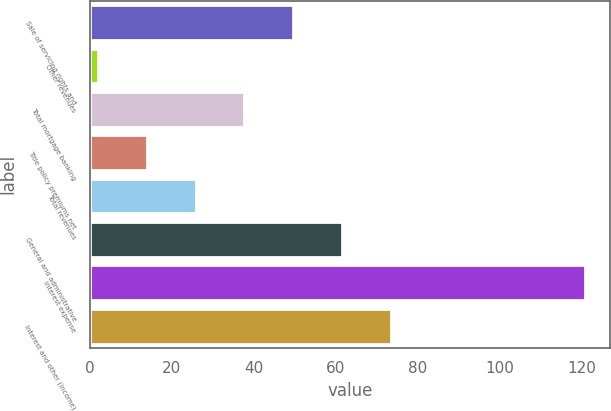Convert chart to OTSL. <chart><loc_0><loc_0><loc_500><loc_500><bar_chart><fcel>Sale of servicing rights and<fcel>Other revenues<fcel>Total mortgage banking<fcel>Title policy premiums net<fcel>Total revenues<fcel>General and administrative<fcel>Interest expense<fcel>Interest and other (income)<nl><fcel>49.6<fcel>2<fcel>37.7<fcel>13.9<fcel>25.8<fcel>61.5<fcel>121<fcel>73.4<nl></chart> 